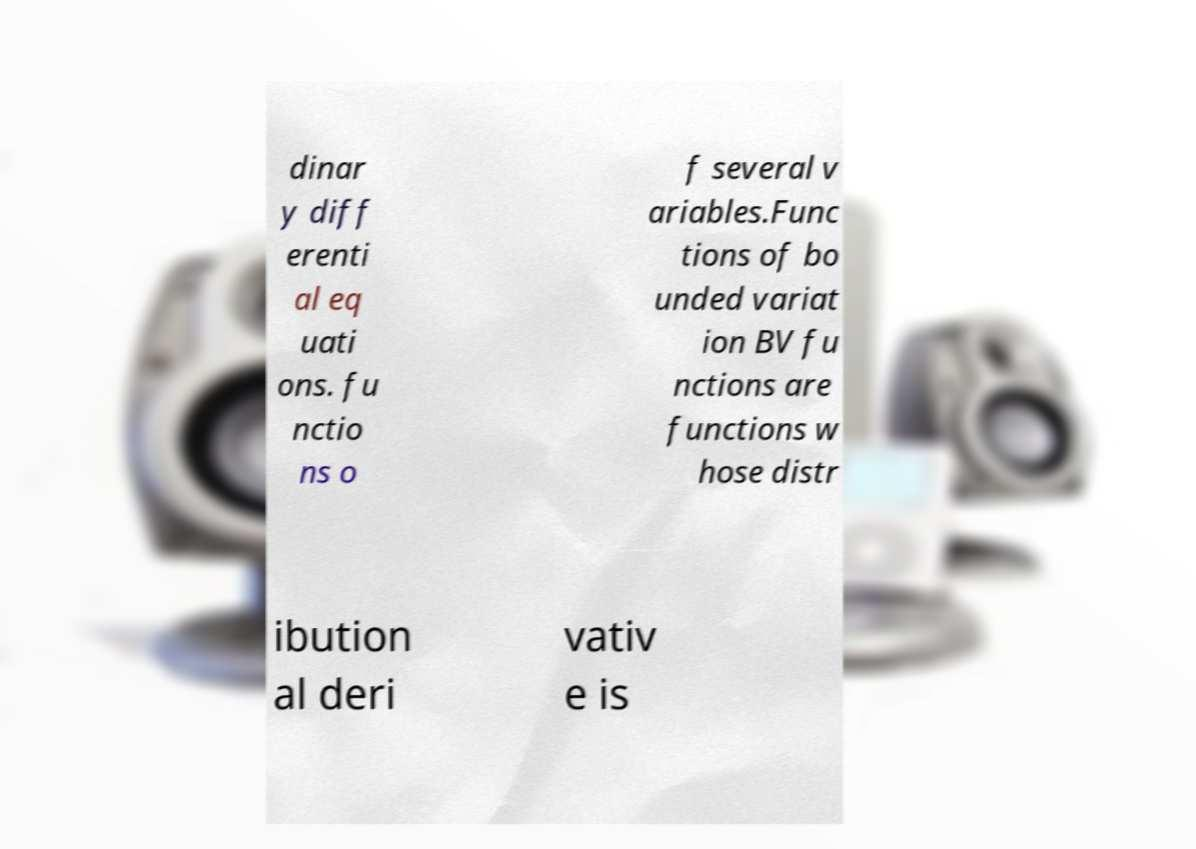Could you assist in decoding the text presented in this image and type it out clearly? dinar y diff erenti al eq uati ons. fu nctio ns o f several v ariables.Func tions of bo unded variat ion BV fu nctions are functions w hose distr ibution al deri vativ e is 